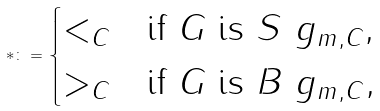Convert formula to latex. <formula><loc_0><loc_0><loc_500><loc_500>\ast \colon = \begin{cases} < _ { C } & \text {if } G \text { is } S ^ { \ } g _ { m , C } , \\ > _ { C } & \text {if } G \text { is } B ^ { \ } g _ { m , C } , \end{cases}</formula> 